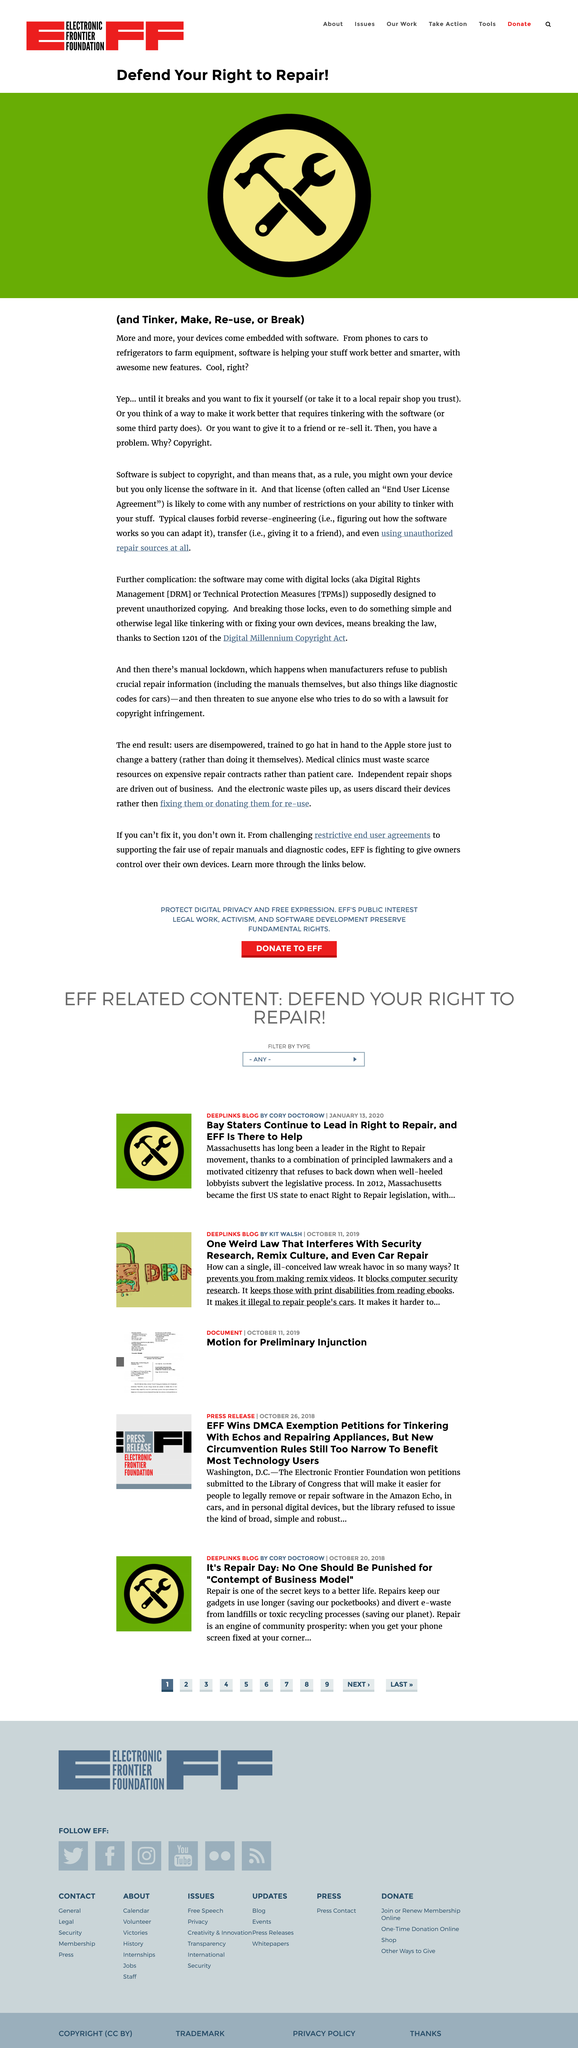Highlight a few significant elements in this photo. Software is subject to copyright. I assert my right to repair, tinker, make, re-use, or break any object as guaranteed by law, as defended in this article. More and more devices are being embedded with software. 